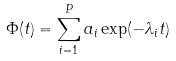Convert formula to latex. <formula><loc_0><loc_0><loc_500><loc_500>\Phi ( t ) = \sum _ { i = 1 } ^ { P } a _ { i } \exp ( - \lambda _ { i } t )</formula> 